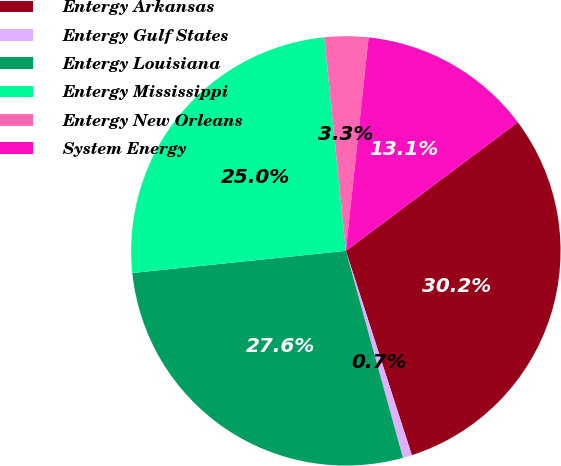Convert chart. <chart><loc_0><loc_0><loc_500><loc_500><pie_chart><fcel>Entergy Arkansas<fcel>Entergy Gulf States<fcel>Entergy Louisiana<fcel>Entergy Mississippi<fcel>Entergy New Orleans<fcel>System Energy<nl><fcel>30.25%<fcel>0.69%<fcel>27.64%<fcel>25.04%<fcel>3.29%<fcel>13.09%<nl></chart> 